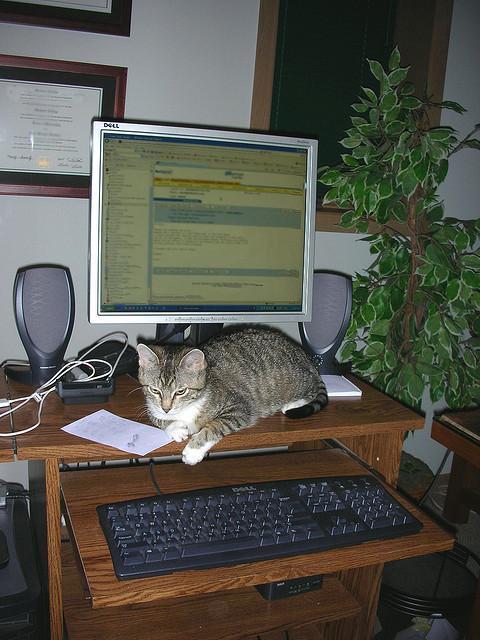How many speakers are there?
Give a very brief answer. 2. 